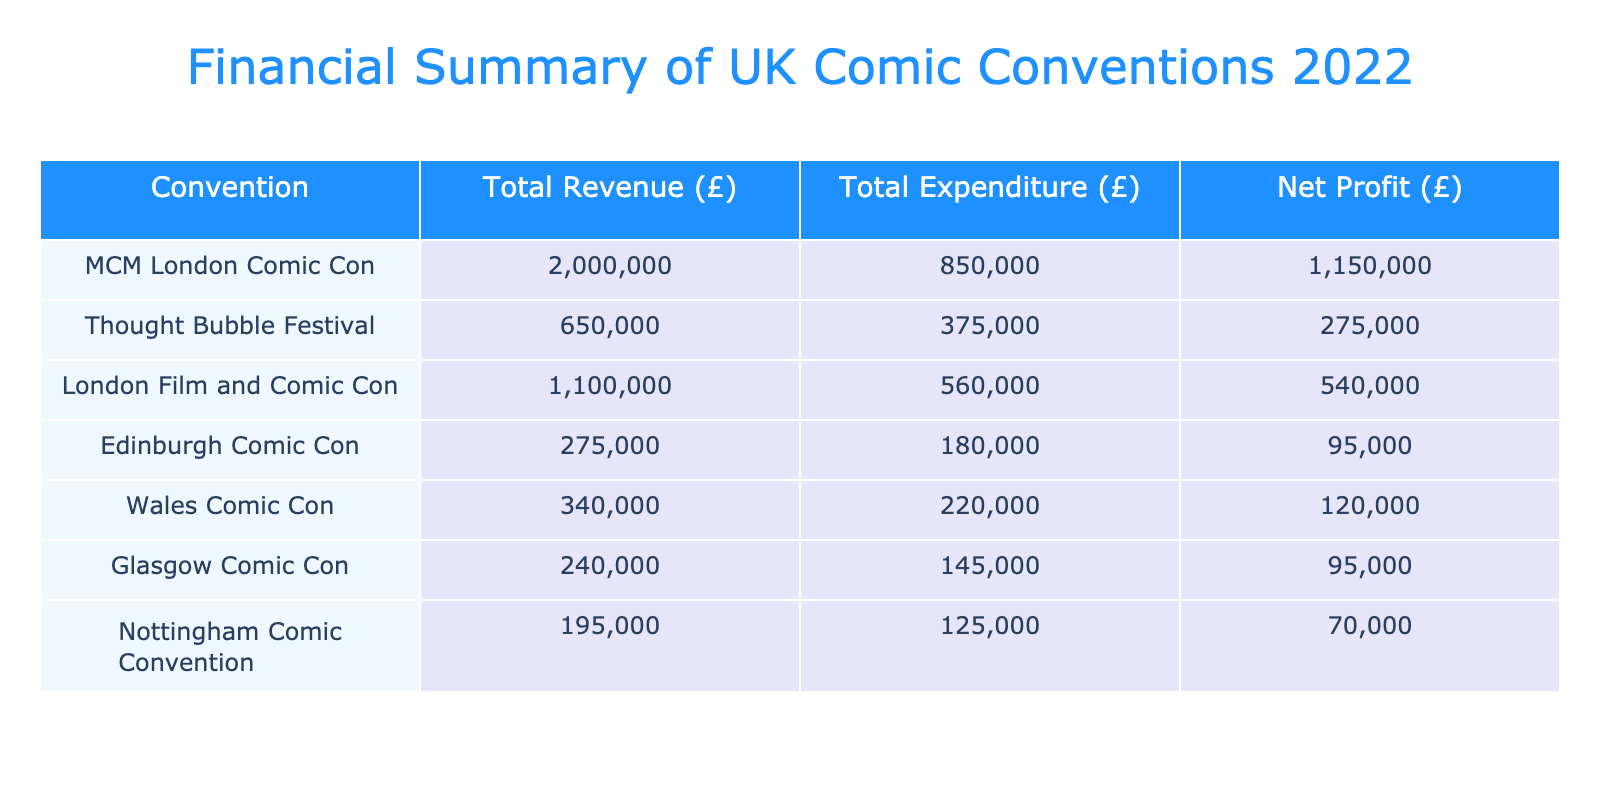What is the total revenue of MCM London Comic Con? The table shows that the total revenue for MCM London Comic Con is calculated as the sum of its ticket sales (£1,500,000), merchandise (£300,000), and sponsorship (£200,000). This results in a total revenue of £1,500,000 + £300,000 + £200,000 = £2,000,000.
Answer: £2,000,000 What is the net profit for Thought Bubble Festival? To find the net profit for Thought Bubble Festival, we first need to calculate its total revenue, which is £500,000 (ticket sales) + £100,000 (merchandise) + £50,000 (sponsorship) = £650,000. Total expenditure is £200,000 (venue) + £100,000 (staffing) + £50,000 (marketing) + £25,000 (miscellaneous) = £375,000. The net profit is then £650,000 - £375,000 = £275,000.
Answer: £275,000 Which convention had the highest total expenditure? The total expenditure for each convention is as follows: MCM London Comic Con (£850,000), Thought Bubble Festival (£375,000), London Film and Comic Con (£555,000), Edinburgh Comic Con (£220,000), Wales Comic Con (£210,000), Glasgow Comic Con (£175,000), and Nottingham Comic Convention (£121,000). Comparing these values, MCM London Comic Con has the highest total expenditure of £850,000.
Answer: £850,000 Is Glasgow Comic Con profitable? To determine if Glasgow Comic Con is profitable, we look at its total revenue (£180,000) and total expenditure (£170,000). The net profit is calculated as £180,000 - £170,000 = £10,000. Since the net profit is positive, it is profitable.
Answer: Yes What is the average net profit of all conventions? First, we calculate the net profit for each convention: MCM London Comic Con (£1,150,000), Thought Bubble Festival (£275,000), London Film and Comic Con (£245,000), Edinburgh Comic Con (£80,000), Wales Comic Con (£10,000), Glasgow Comic Con (£10,000), and Nottingham Comic Convention (£29,000). The total net profit is £1,150,000 + £275,000 + £245,000 + £80,000 + £10,000 + £10,000 + £29,000 = £1,799,000. There are 7 conventions, so the average net profit is £1,799,000 / 7 ≈ £257,000.
Answer: £257,000 